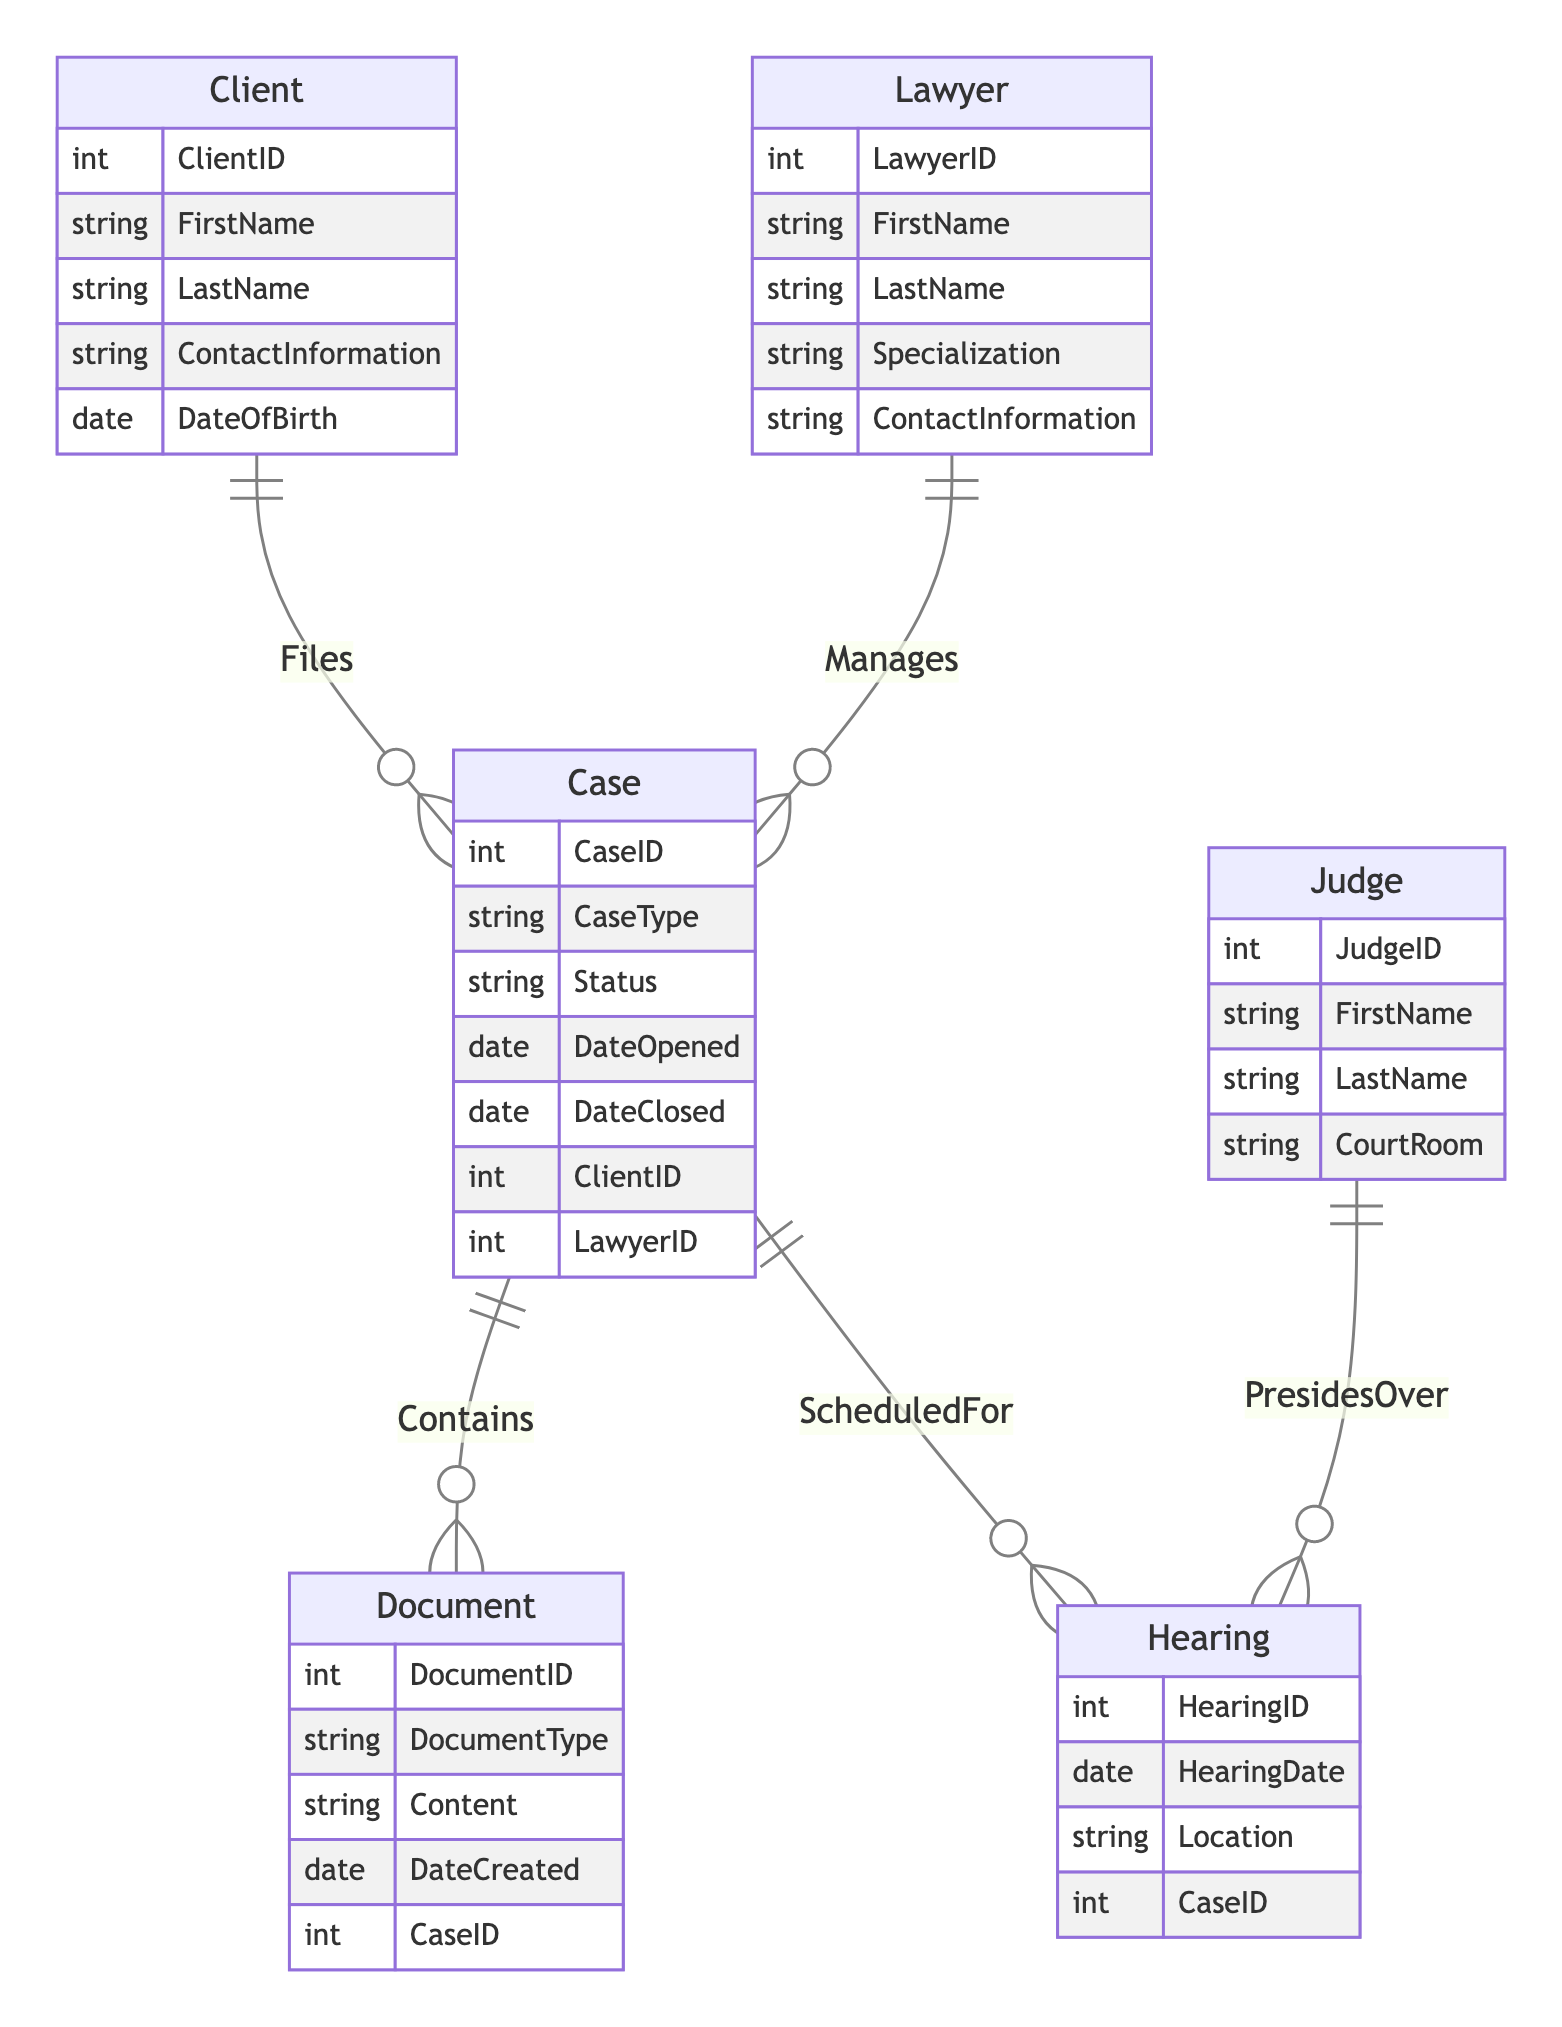What is the primary relationship between Lawyer and Case? The primary relationship is represented as "Manages," which indicates that a Lawyer can manage multiple Cases. This can be seen in the relationship section of the diagram where it states the relationship and its cardinality as "1-to-Many."
Answer: Manages How many attributes does the Client entity have? The Client entity is listed with five attributes: ClientID, FirstName, LastName, ContactInformation, and DateOfBirth. This can be counted directly from the attributes defined under the Client entity.
Answer: Five Which entity contains the Hearing entity? The Hearing entity is connected to the Case entity through the "ScheduledFor" relationship. This means every Hearing entity is associated with one Case that it's scheduled for. The relationship type also indicates this connection.
Answer: Case What is the count of relationships involving the Case entity? The Case entity is involved in four relationships: "Contains" (with Document), "ScheduledFor" (with Hearing), "Manages" (with Lawyer), and "Files" (with Client). Counting these relationships gives us a total of four.
Answer: Four What is the specialization attribute in the Lawyer entity? The specialization attribute is one of the attributes present in the Lawyer entity. It indicates the specific area or field of law in which the Lawyer specializes. The attribute is listed explicitly under the Lawyer entity's attributes.
Answer: Specialization Which entity presides over Hearings? The Judge entity is connected to the Hearing entity through the "PresidesOver" relationship. This indicates that a Judge presides over multiple Hearings, establishing a clear relationship in the diagram.
Answer: Judge What is the purpose of the Document entity in relation to the Case? The Document entity is associated with the Case entity through the "Contains" relationship, meaning that a Case can contain multiple Documents relevant to it. This is directly pointed out by the relationship defined in the diagram.
Answer: Contains How many entities are represented in the diagram? The diagram represents six entities: Client, Lawyer, Case, Document, Hearing, and Judge. Counting these entities will lead to the total representation.
Answer: Six What date-related attribute does the Case entity have? The Case entity has two date-related attributes: DateOpened and DateClosed. These attributes are essential in indicating the timeline during which a case occurs. Both of these are listed under the attributes for the Case entity.
Answer: DateOpened, DateClosed 